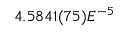<formula> <loc_0><loc_0><loc_500><loc_500>4 . 5 8 4 1 ( 7 5 ) E ^ { - 5 }</formula> 